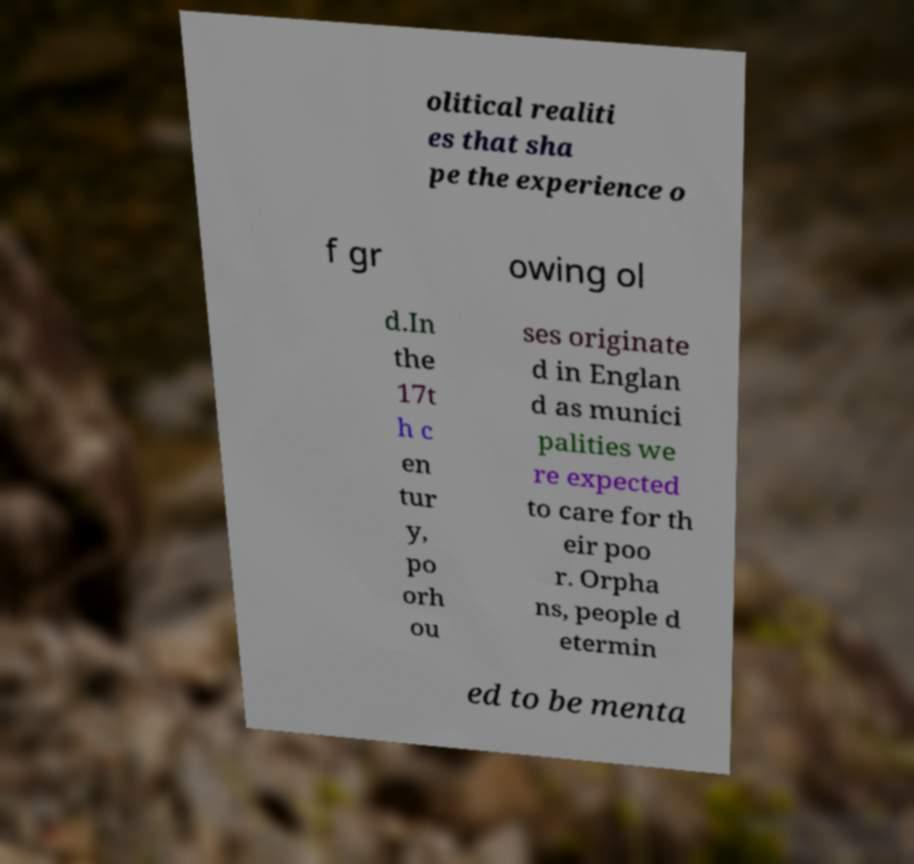Can you read and provide the text displayed in the image?This photo seems to have some interesting text. Can you extract and type it out for me? olitical realiti es that sha pe the experience o f gr owing ol d.In the 17t h c en tur y, po orh ou ses originate d in Englan d as munici palities we re expected to care for th eir poo r. Orpha ns, people d etermin ed to be menta 